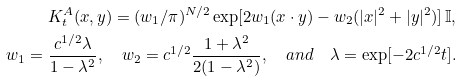Convert formula to latex. <formula><loc_0><loc_0><loc_500><loc_500>K _ { t } ^ { A } ( x , y ) = ( w _ { 1 } / \pi ) ^ { N / 2 } \exp [ 2 w _ { 1 } ( x \cdot y ) - w _ { 2 } ( | x | ^ { 2 } + | y | ^ { 2 } ) ] \, \mathbb { I } , \\ w _ { 1 } = \frac { c ^ { 1 / 2 } \lambda } { 1 - \lambda ^ { 2 } } , \quad w _ { 2 } = c ^ { 1 / 2 } \frac { 1 + \lambda ^ { 2 } } { 2 ( 1 - \lambda ^ { 2 } ) } , \quad a n d \quad \lambda = \exp [ - 2 c ^ { 1 / 2 } t ] .</formula> 